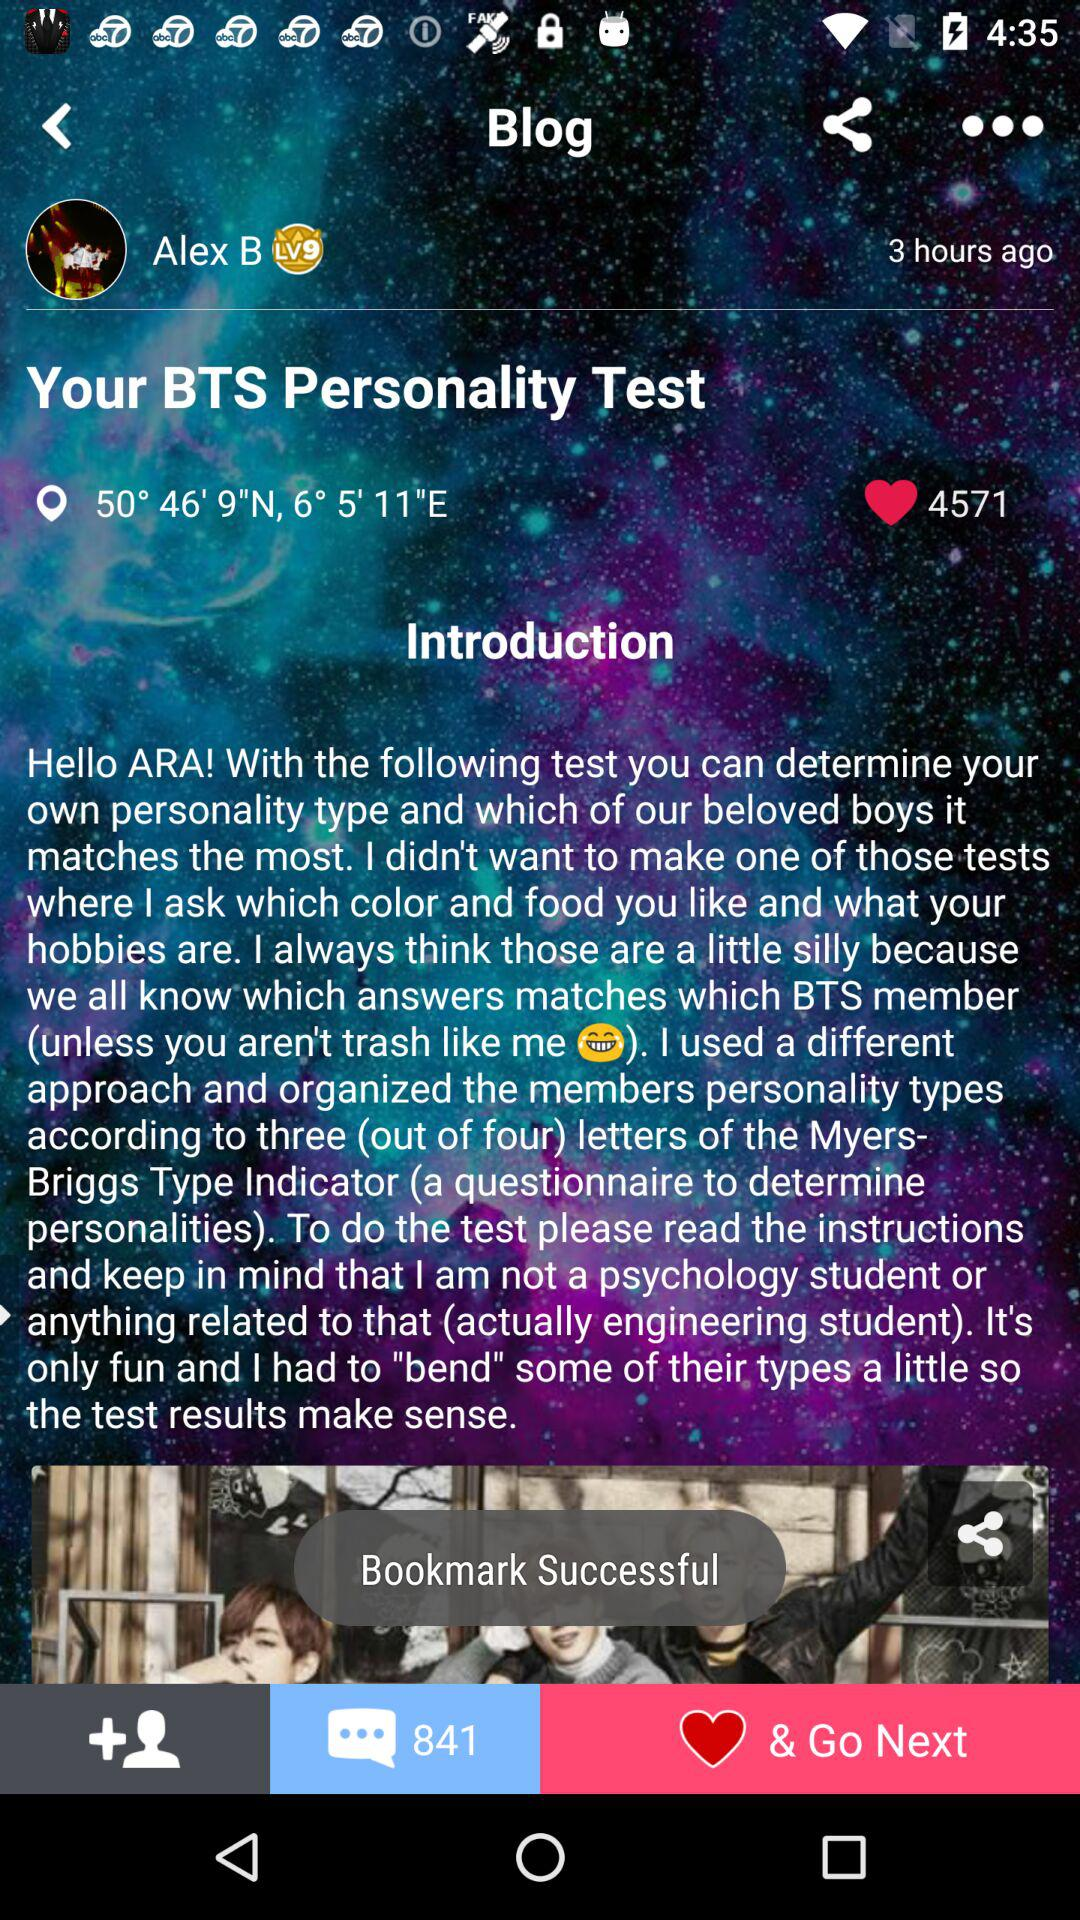What is the title of the blog? The title of the blog is "Your BTS Personality Test". 